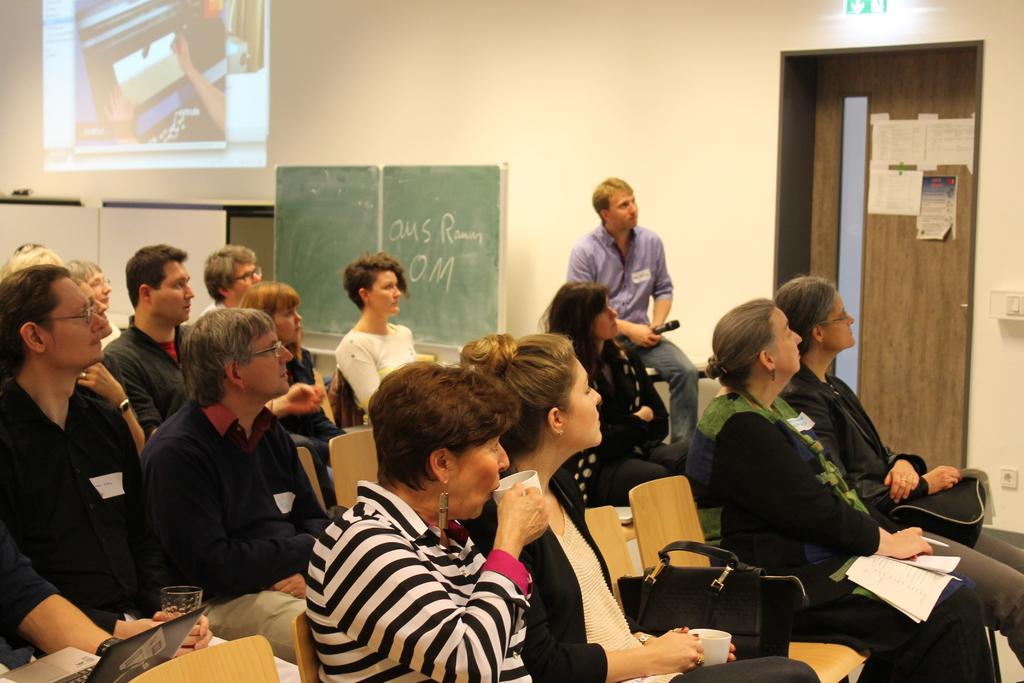Please provide a concise description of this image. In this image we can see persons sitting on the chairs and some of them are holding coffee mugs, bags and stationary in their hands. In the background we can see projector display, board, walls, papers pasted on the door, sign board, electric notch, mic and a laptop. 